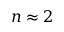<formula> <loc_0><loc_0><loc_500><loc_500>n \approx 2</formula> 